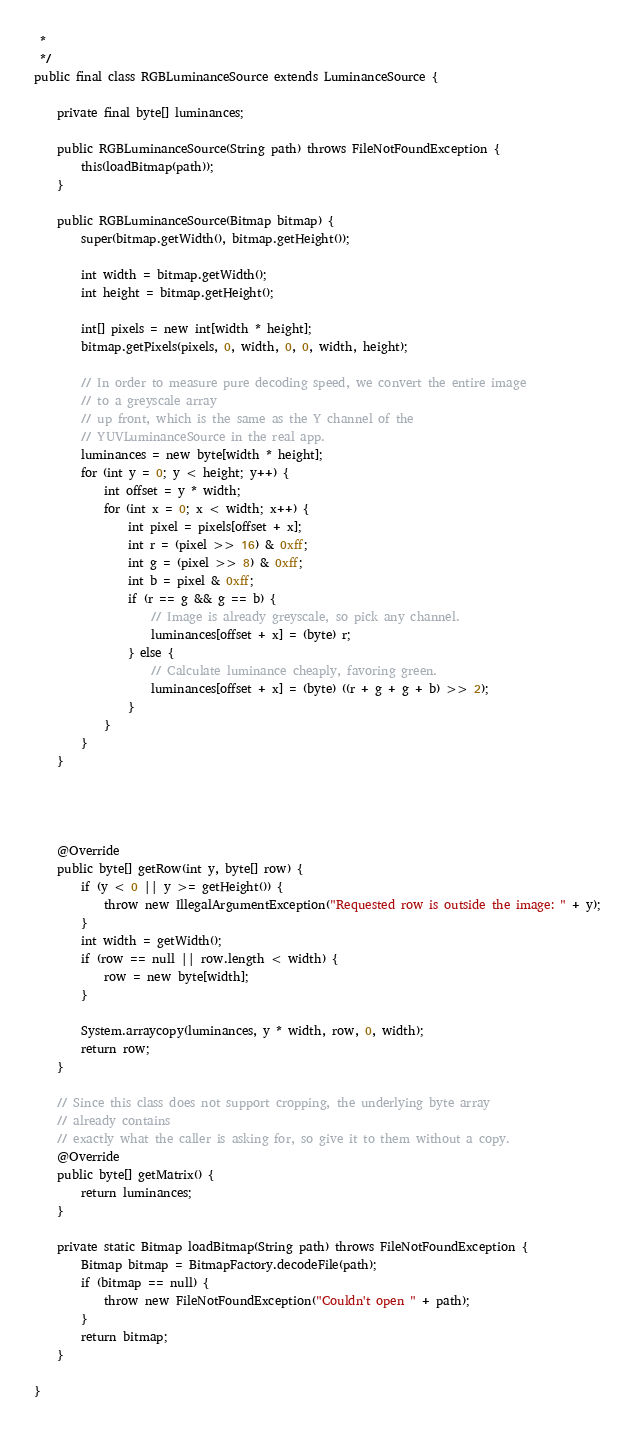Convert code to text. <code><loc_0><loc_0><loc_500><loc_500><_Java_> * 
 */
public final class RGBLuminanceSource extends LuminanceSource {

	private final byte[] luminances;

	public RGBLuminanceSource(String path) throws FileNotFoundException {
		this(loadBitmap(path));
	}

	public RGBLuminanceSource(Bitmap bitmap) {
		super(bitmap.getWidth(), bitmap.getHeight());

		int width = bitmap.getWidth();
		int height = bitmap.getHeight();

		int[] pixels = new int[width * height];
		bitmap.getPixels(pixels, 0, width, 0, 0, width, height);

		// In order to measure pure decoding speed, we convert the entire image
		// to a greyscale array
		// up front, which is the same as the Y channel of the
		// YUVLuminanceSource in the real app.
		luminances = new byte[width * height];
		for (int y = 0; y < height; y++) {
			int offset = y * width;
			for (int x = 0; x < width; x++) {
				int pixel = pixels[offset + x];
				int r = (pixel >> 16) & 0xff;
				int g = (pixel >> 8) & 0xff;
				int b = pixel & 0xff;
				if (r == g && g == b) {
					// Image is already greyscale, so pick any channel.
					luminances[offset + x] = (byte) r;
				} else {
					// Calculate luminance cheaply, favoring green.
					luminances[offset + x] = (byte) ((r + g + g + b) >> 2);
				}
			}
		}
	}




	@Override
	public byte[] getRow(int y, byte[] row) {
		if (y < 0 || y >= getHeight()) {
			throw new IllegalArgumentException("Requested row is outside the image: " + y);
		}
		int width = getWidth();
		if (row == null || row.length < width) {
			row = new byte[width];
		}

		System.arraycopy(luminances, y * width, row, 0, width);
		return row;
	}

	// Since this class does not support cropping, the underlying byte array
	// already contains
	// exactly what the caller is asking for, so give it to them without a copy.
	@Override
	public byte[] getMatrix() {
		return luminances;
	}

	private static Bitmap loadBitmap(String path) throws FileNotFoundException {
		Bitmap bitmap = BitmapFactory.decodeFile(path);
		if (bitmap == null) {
			throw new FileNotFoundException("Couldn't open " + path);
		}
		return bitmap;
	}

}
</code> 